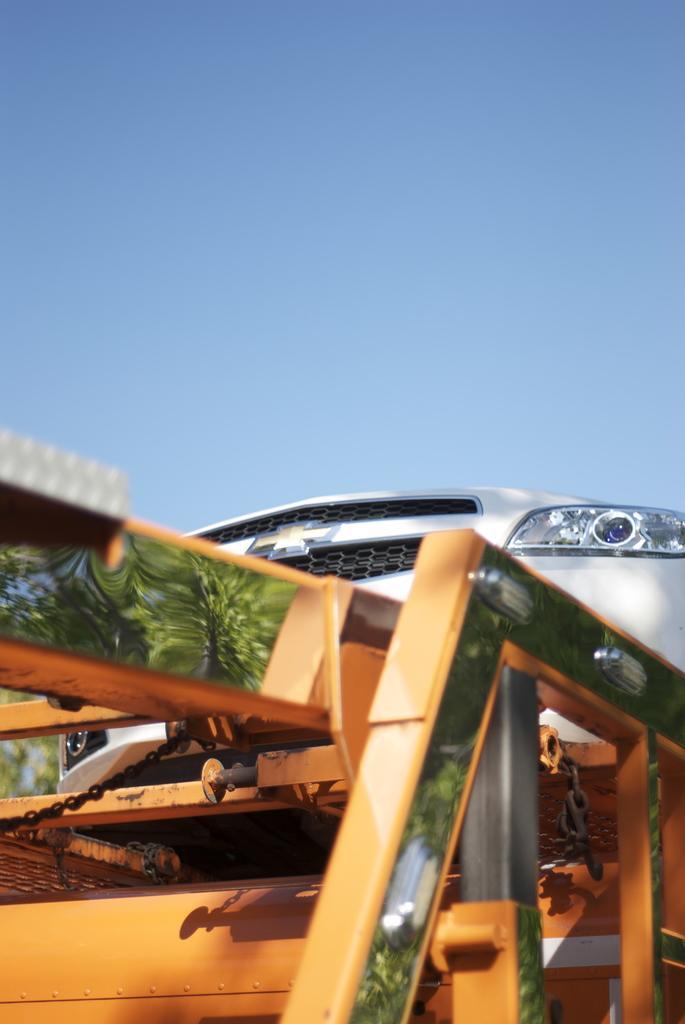Describe this image in one or two sentences. In this image there is a car on the towing vehicle. 